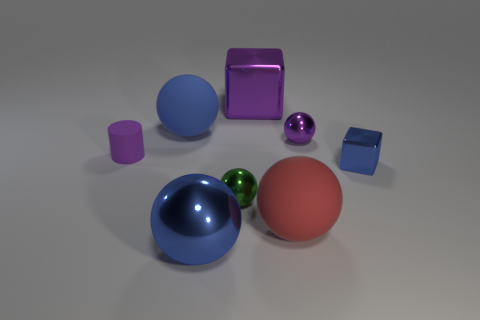There is another small object that is the same shape as the small green thing; what color is it?
Give a very brief answer. Purple. What is the color of the metal ball right of the large rubber thing that is in front of the tiny green metallic sphere?
Give a very brief answer. Purple. What is the shape of the purple rubber thing?
Your answer should be very brief. Cylinder. What shape is the purple object that is both left of the small purple metal sphere and in front of the large metal block?
Your answer should be very brief. Cylinder. There is a small cylinder that is made of the same material as the big red object; what color is it?
Ensure brevity in your answer.  Purple. What shape is the tiny purple thing left of the large blue thing behind the big matte sphere that is right of the big purple object?
Offer a terse response. Cylinder. The red rubber object is what size?
Offer a terse response. Large. There is a big blue thing that is made of the same material as the red sphere; what is its shape?
Your answer should be very brief. Sphere. Is the number of small matte things right of the large blue rubber sphere less than the number of blocks?
Ensure brevity in your answer.  Yes. The big matte thing to the left of the big red thing is what color?
Provide a succinct answer. Blue. 